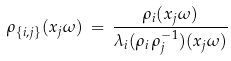<formula> <loc_0><loc_0><loc_500><loc_500>\rho _ { \{ i , j \} } ( x _ { j } \omega ) \, = \, \frac { \rho _ { i } ( x _ { j } \omega ) } { \lambda _ { i } ( \rho _ { i } \, \rho _ { j } ^ { - 1 } ) ( x _ { j } \omega ) }</formula> 